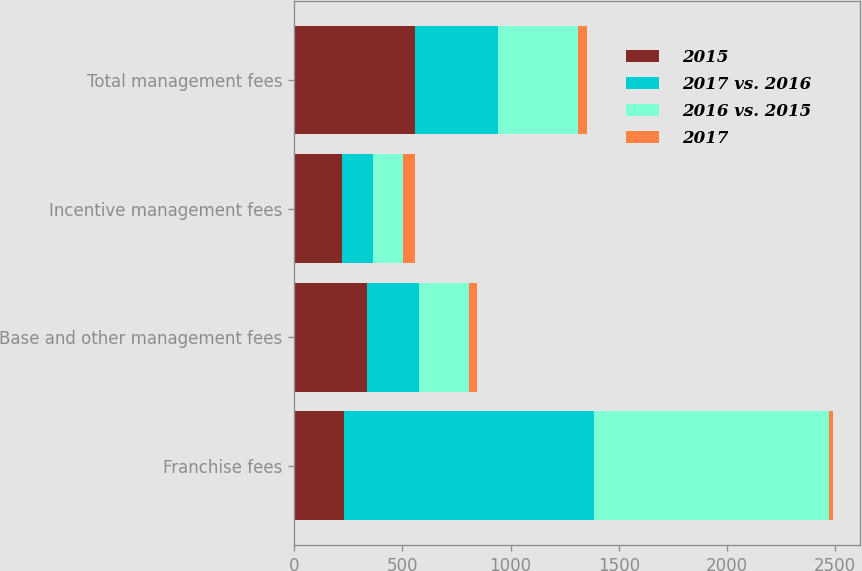Convert chart to OTSL. <chart><loc_0><loc_0><loc_500><loc_500><stacked_bar_chart><ecel><fcel>Franchise fees<fcel>Base and other management fees<fcel>Incentive management fees<fcel>Total management fees<nl><fcel>2015<fcel>230<fcel>336<fcel>222<fcel>558<nl><fcel>2017 vs. 2016<fcel>1154<fcel>242<fcel>142<fcel>384<nl><fcel>2016 vs. 2015<fcel>1087<fcel>230<fcel>138<fcel>368<nl><fcel>2017<fcel>19.8<fcel>38.8<fcel>56.3<fcel>45.3<nl></chart> 